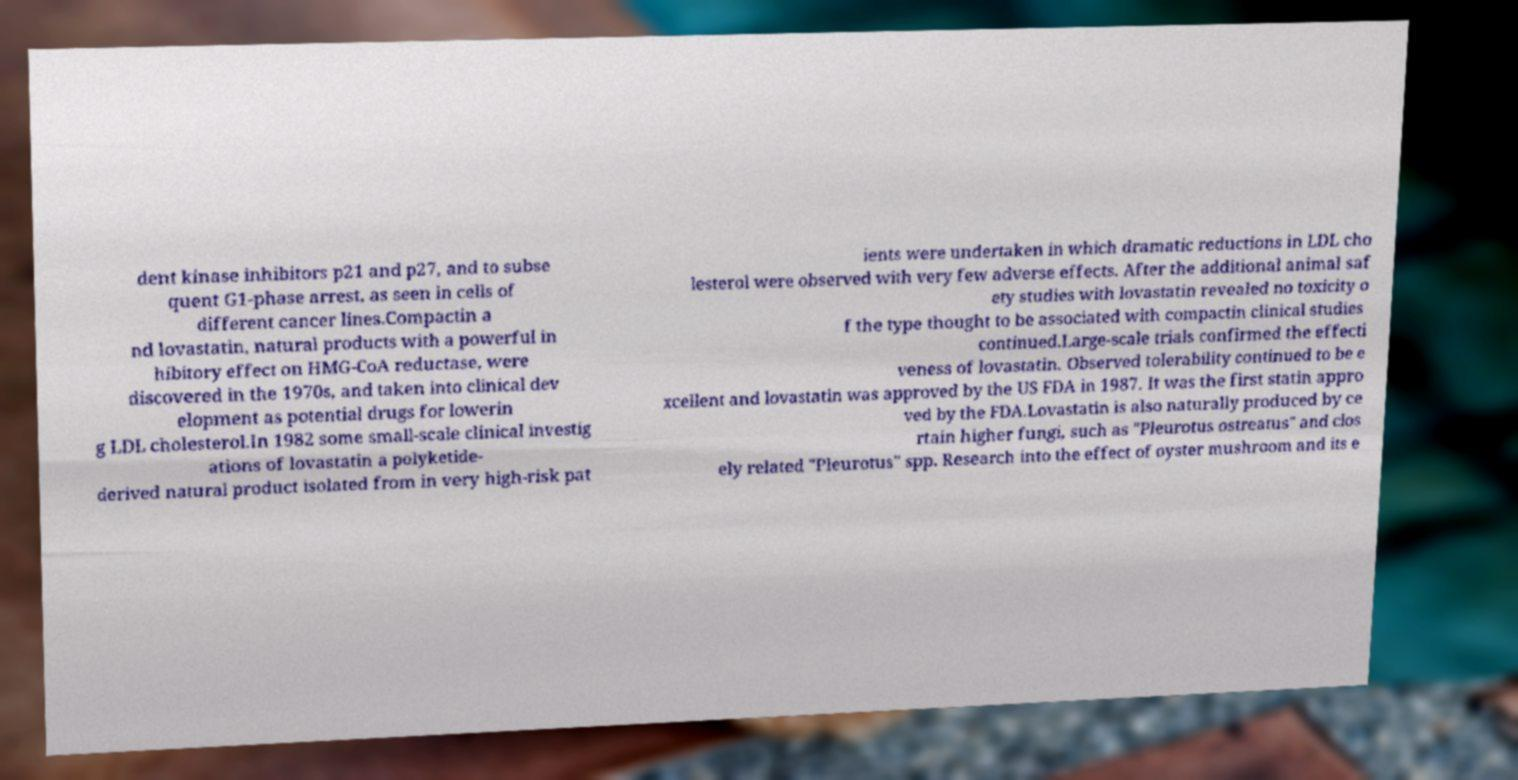Please read and relay the text visible in this image. What does it say? dent kinase inhibitors p21 and p27, and to subse quent G1-phase arrest, as seen in cells of different cancer lines.Compactin a nd lovastatin, natural products with a powerful in hibitory effect on HMG-CoA reductase, were discovered in the 1970s, and taken into clinical dev elopment as potential drugs for lowerin g LDL cholesterol.In 1982 some small-scale clinical investig ations of lovastatin a polyketide- derived natural product isolated from in very high-risk pat ients were undertaken in which dramatic reductions in LDL cho lesterol were observed with very few adverse effects. After the additional animal saf ety studies with lovastatin revealed no toxicity o f the type thought to be associated with compactin clinical studies continued.Large-scale trials confirmed the effecti veness of lovastatin. Observed tolerability continued to be e xcellent and lovastatin was approved by the US FDA in 1987. It was the first statin appro ved by the FDA.Lovastatin is also naturally produced by ce rtain higher fungi, such as "Pleurotus ostreatus" and clos ely related "Pleurotus" spp. Research into the effect of oyster mushroom and its e 